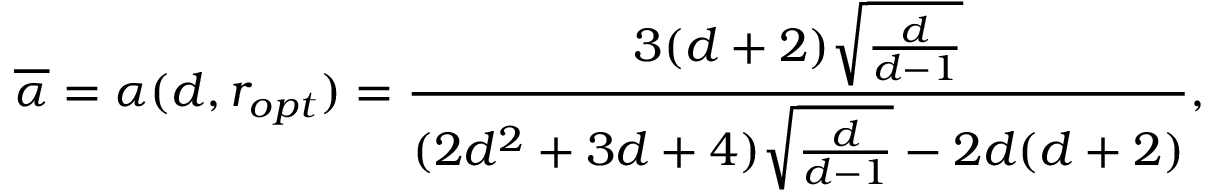Convert formula to latex. <formula><loc_0><loc_0><loc_500><loc_500>\overline { \alpha } = \alpha ( d , r _ { o p t } ) = \frac { 3 ( d + 2 ) \sqrt { \frac { d } { d - 1 } } } { ( 2 d ^ { 2 } + 3 d + 4 ) \sqrt { \frac { d } { d - 1 } } - 2 d ( d + 2 ) } ,</formula> 